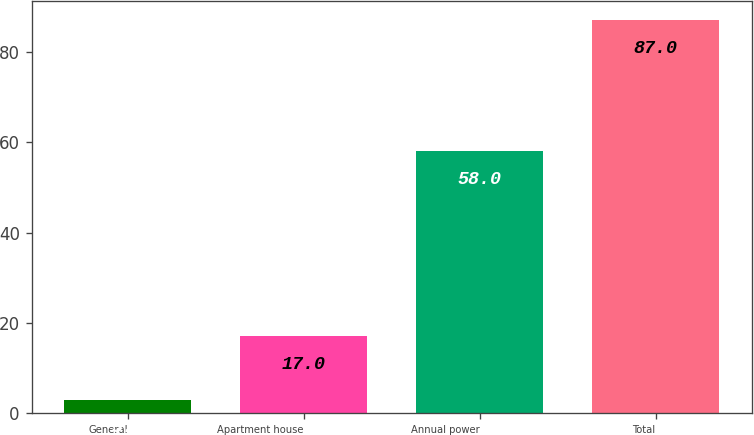Convert chart to OTSL. <chart><loc_0><loc_0><loc_500><loc_500><bar_chart><fcel>General<fcel>Apartment house<fcel>Annual power<fcel>Total<nl><fcel>3<fcel>17<fcel>58<fcel>87<nl></chart> 